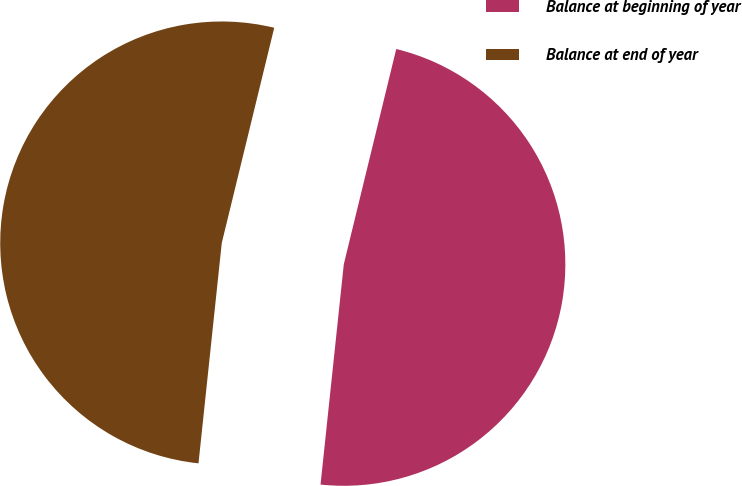Convert chart to OTSL. <chart><loc_0><loc_0><loc_500><loc_500><pie_chart><fcel>Balance at beginning of year<fcel>Balance at end of year<nl><fcel>47.87%<fcel>52.13%<nl></chart> 